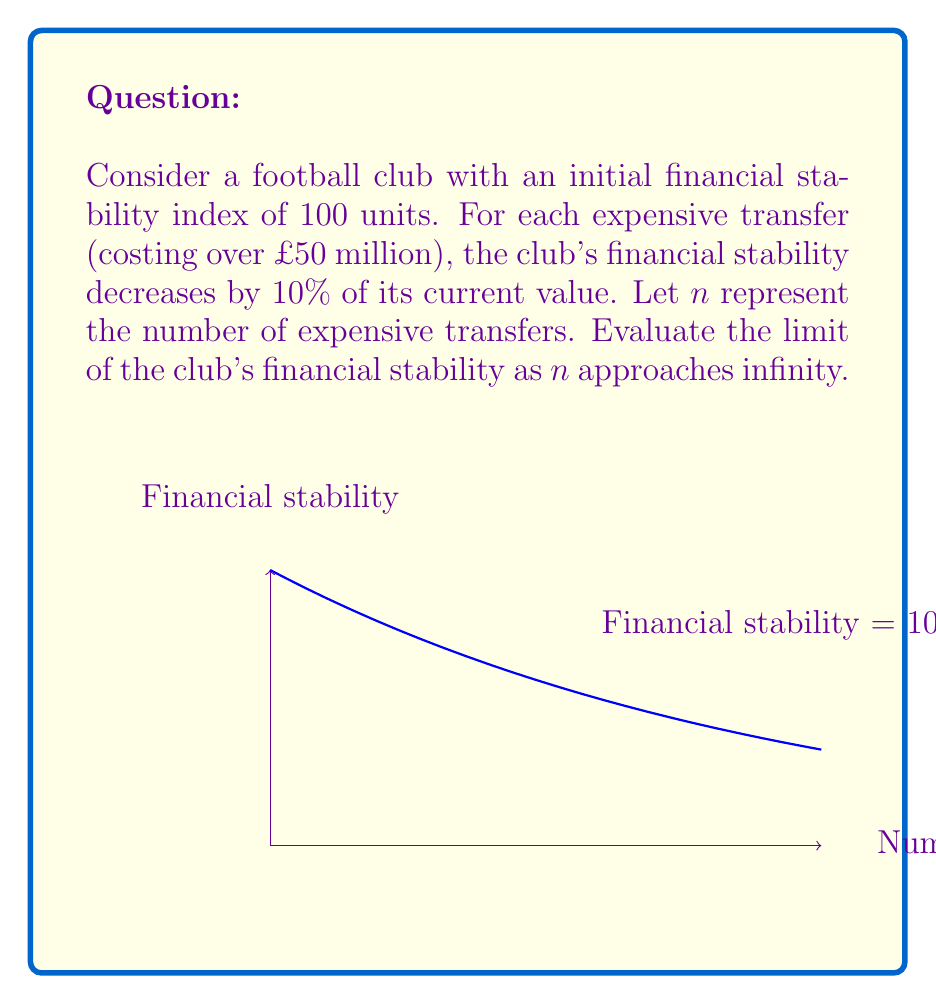Solve this math problem. Let's approach this step-by-step:

1) The initial financial stability is 100 units.

2) After each expensive transfer, the stability decreases by 10%, or multiplies by 0.9.

3) We can express this as a function of $n$:
   $f(n) = 100 \cdot (0.9)^n$

4) To find the limit as $n$ approaches infinity:
   $\lim_{n \to \infty} f(n) = \lim_{n \to \infty} 100 \cdot (0.9)^n$

5) We can separate the constant:
   $\lim_{n \to \infty} f(n) = 100 \cdot \lim_{n \to \infty} (0.9)^n$

6) Now, we need to evaluate $\lim_{n \to \infty} (0.9)^n$. Since $0 < 0.9 < 1$, we know that:
   $\lim_{n \to \infty} (0.9)^n = 0$

7) Therefore:
   $\lim_{n \to \infty} f(n) = 100 \cdot 0 = 0$

This means that as the number of expensive transfers approaches infinity, the club's financial stability approaches zero.
Answer: $0$ 